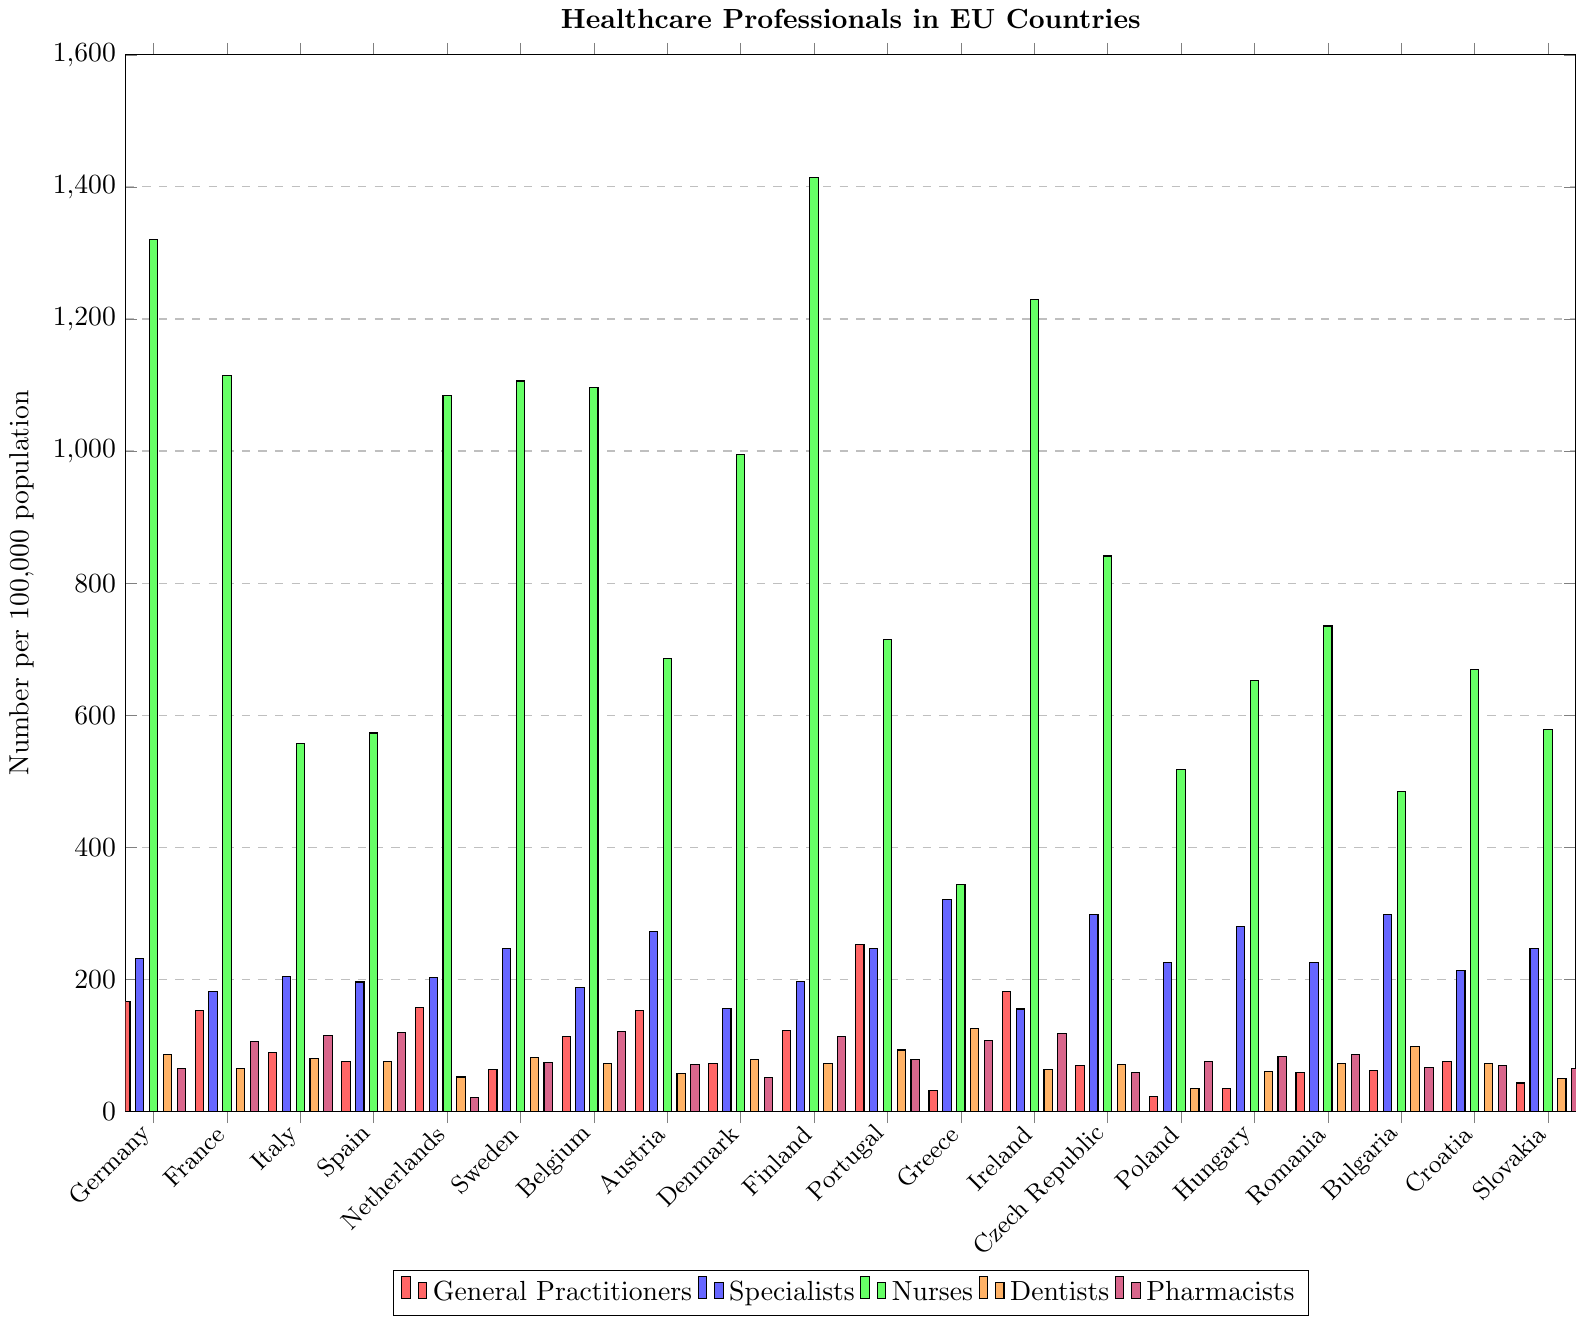What country has the highest number of general practitioners per 100,000 population? From the bar chart, look for the tallest bar in the category of "General Practitioners" which is represented in red. Portugal has the highest number of general practitioners per 100,000 population with a value of 253.
Answer: Portugal Which country has more nurses per 100,000 population, Germany or Finland? From the bar chart, compare the heights of the green bars for Germany and Finland. Germany has 1320 nurses while Finland has 1414 nurses per 100,000 population.
Answer: Finland Among the listed EU countries, identify the country with the lowest number of pharmacists per 100,000 population. From the bar chart, find the shortest purple bar in the category of "Pharmacists." The Netherlands has the lowest number of pharmacists per 100,000 population with a value of 21.
Answer: Netherlands Compare the number of specialists and dentists in France. How many more specialists than dentists are there? From the bar chart, observe that France has 181 specialists (blue) and 65 dentists (orange). The difference is 181 - 65 = 116.
Answer: 116 What is the combined total number of healthcare professionals (general practitioners, specialists, nurses, dentists, and pharmacists) per 100,000 population in Greece? Sum the relevant values for Greece: General Practitioners (31) + Specialists (321) + Nurses (343) + Dentists (125) + Pharmacists (107) = 927.
Answer: 927 Which country has the highest disparity between the number of general practitioners and specialists? Observe the differences for each country between the red bars (general practitioners) and blue bars (specialists). Greece has a significant disparity: Specialists (321) and General Practitioners (31), the difference is 321 - 31 = 290.
Answer: Greece What is the average number of dentists per 100,000 population across the EU countries listed? Add up the values for dentists and divide by the number of countries: (86 + 65 + 80 + 76 + 52 + 82 + 73 + 57 + 78 + 72 + 93 + 125 + 63 + 71 + 35 + 61 + 73 + 98 + 72 + 50)/20 = 1504/20 = 75.2.
Answer: 75.2 Which country has fewer nurses per 100,000 population, Italy or Poland? From the bar chart, compare the heights of the green bars for Italy and Poland. Italy has 557 nurses while Poland has 518 nurses per 100,000 population, indicating Poland has fewer nurses.
Answer: Poland Find the country where the number of pharmacists is exactly the same as the number of general practitioners. From the bar chart, look for countries where the heights of the red and purple bars are equal. Slovakia is the country where both the numbers for pharmacists and general practitioners are 65 per 100,000 population.
Answer: Slovakia 